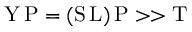Convert formula to latex. <formula><loc_0><loc_0><loc_500><loc_500>Y \, P = ( S \, L ) \, P > > T</formula> 